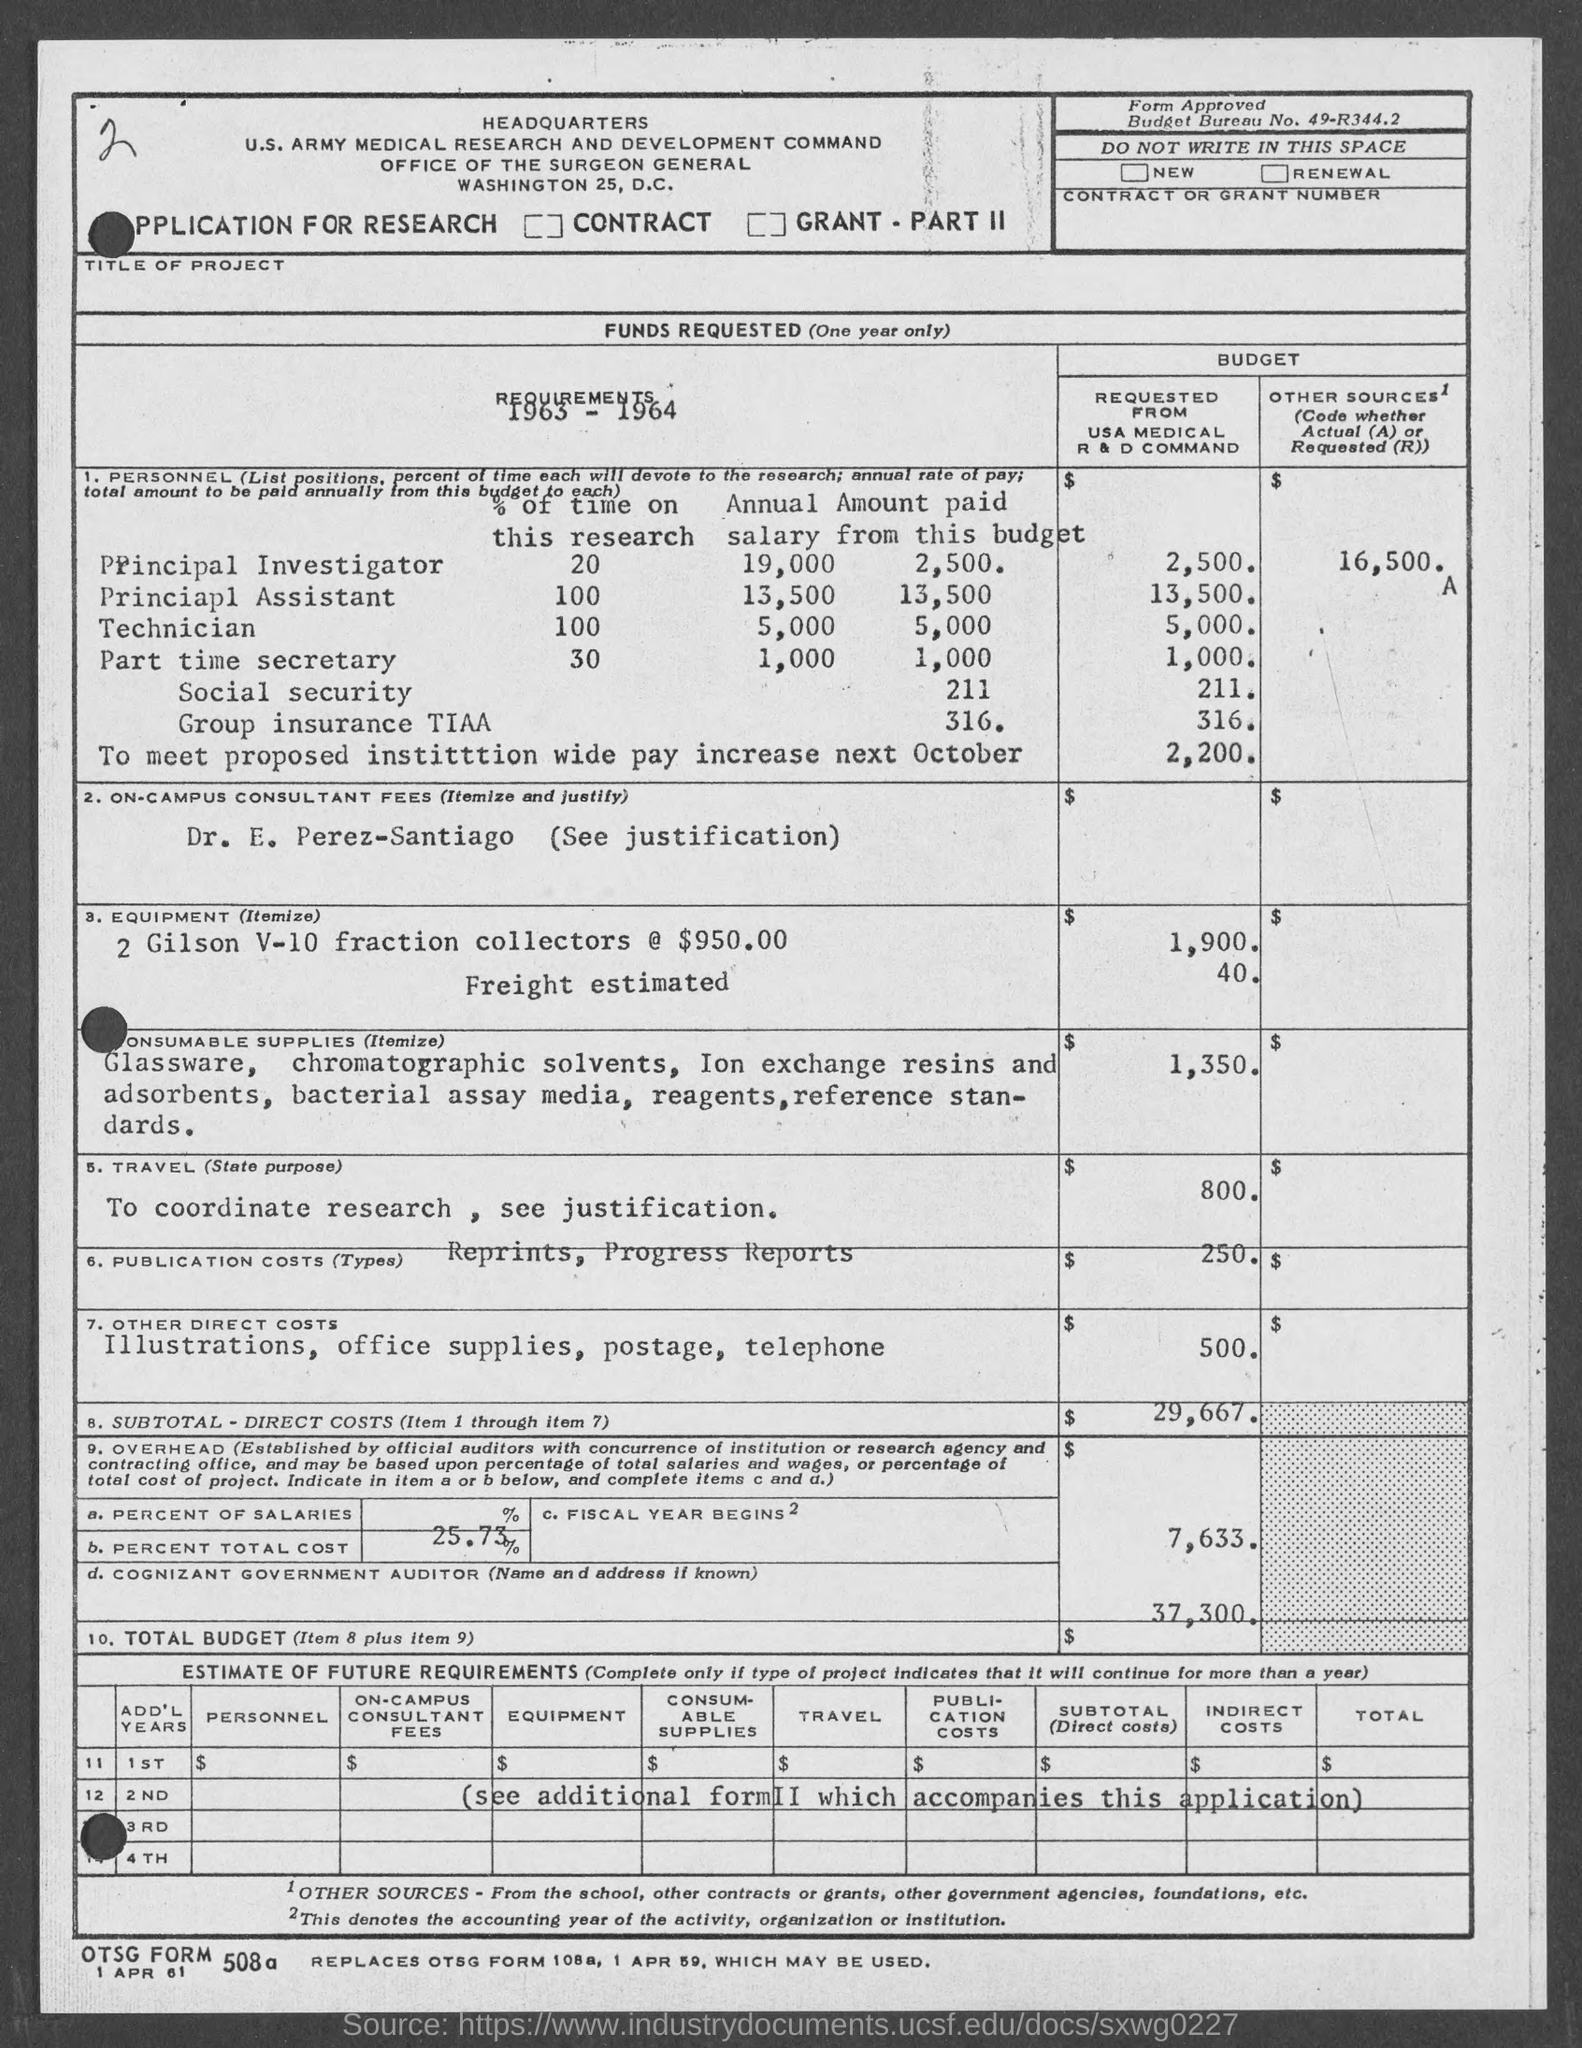What is the Budget Bureau No. given in the application?
Provide a succinct answer. 49-R344.2. What is the total budget requested from USA Medical R & D Command?
Give a very brief answer. $ 37,300. What is the annual salary of a principal investigator?
Your response must be concise. 19,000. What is the annual salary of Principal assistant?
Your response must be concise. 13,500. What is the amount to be paid annually from this budget to the Principal investigator?
Your answer should be very brief. 2,500. What is the percentage of time devoted to the research by Principal Assistant?
Ensure brevity in your answer.  100. What is the percentage of time devoted to the research by Principal Investigator?
Offer a terse response. 20. What is the amount to be  paid annually from this budget to the Principal Assistant?
Ensure brevity in your answer.  13,500. 